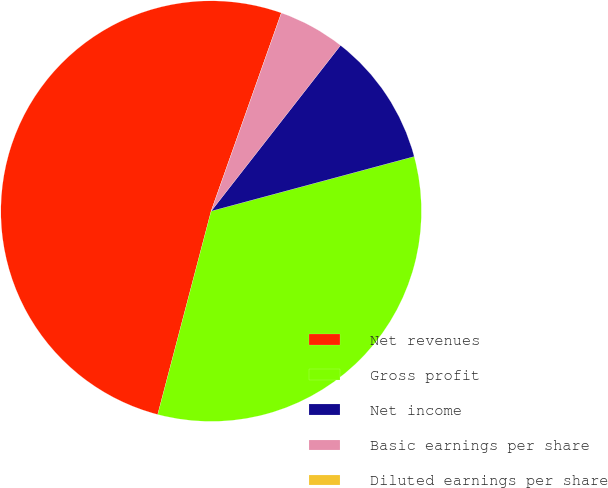Convert chart. <chart><loc_0><loc_0><loc_500><loc_500><pie_chart><fcel>Net revenues<fcel>Gross profit<fcel>Net income<fcel>Basic earnings per share<fcel>Diluted earnings per share<nl><fcel>51.33%<fcel>33.27%<fcel>10.27%<fcel>5.13%<fcel>0.0%<nl></chart> 